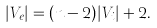<formula> <loc_0><loc_0><loc_500><loc_500>| V _ { e } | = ( n - 2 ) | V _ { i } | + 2 .</formula> 